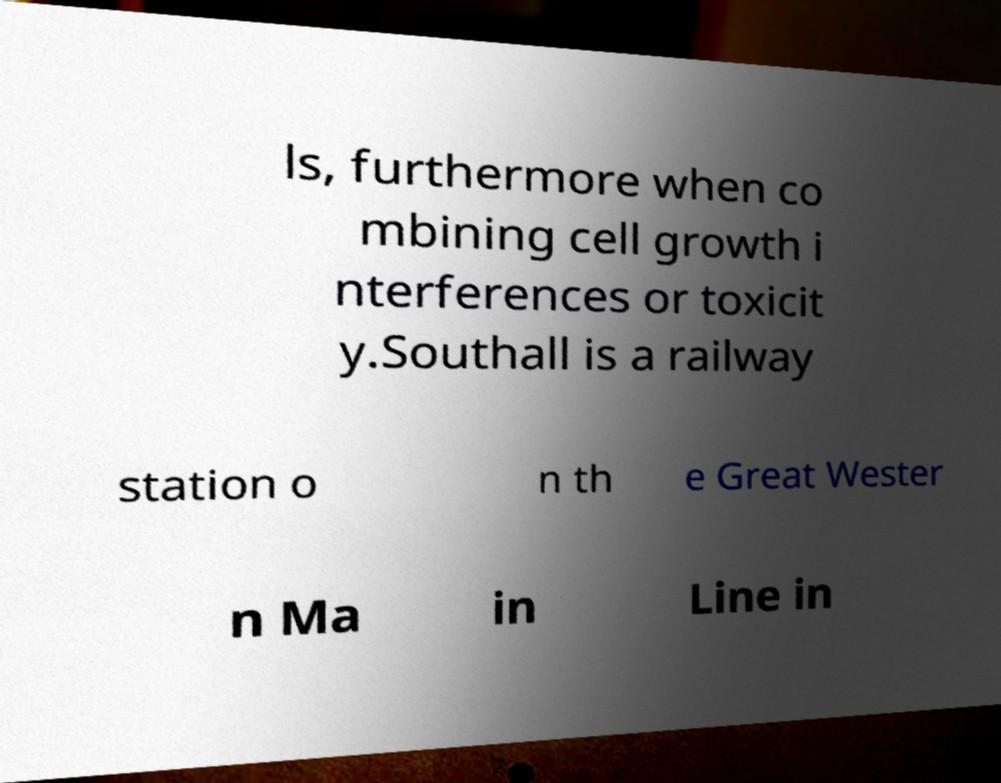What messages or text are displayed in this image? I need them in a readable, typed format. ls, furthermore when co mbining cell growth i nterferences or toxicit y.Southall is a railway station o n th e Great Wester n Ma in Line in 